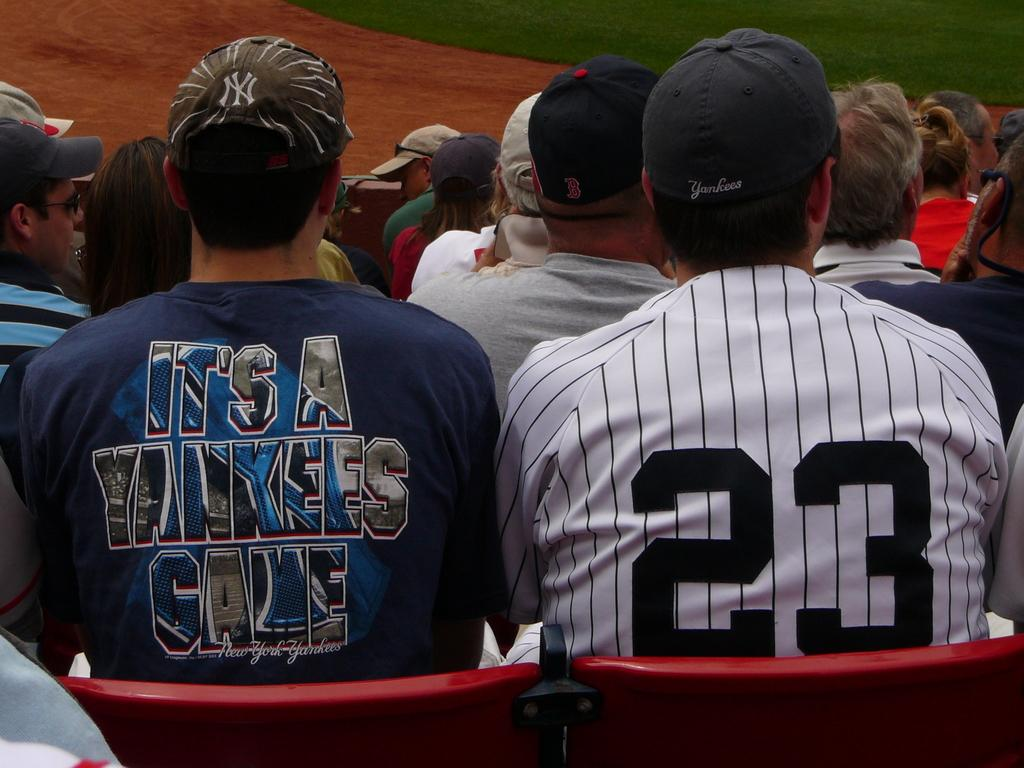<image>
Write a terse but informative summary of the picture. A fan with a 23 jersey watches a baseball game. 